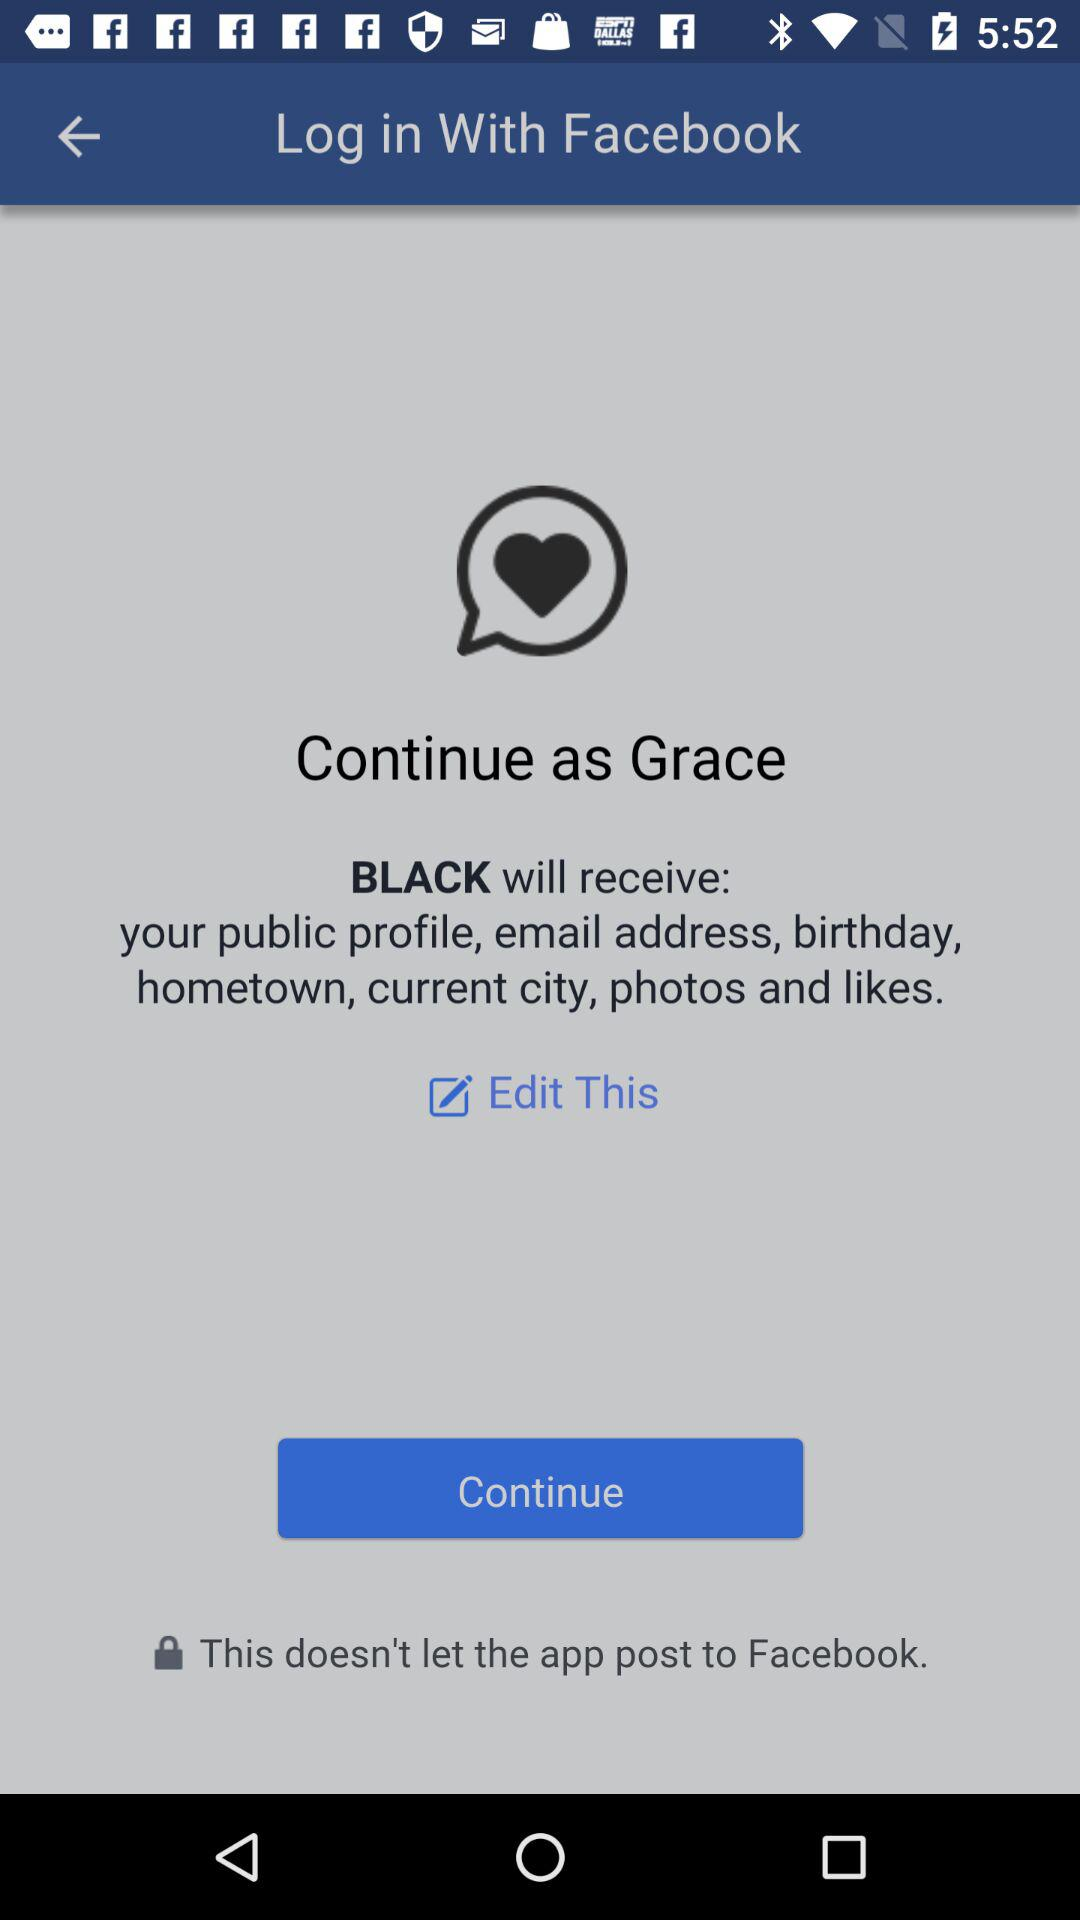What is the name of the user? The name of the user is Grace. 